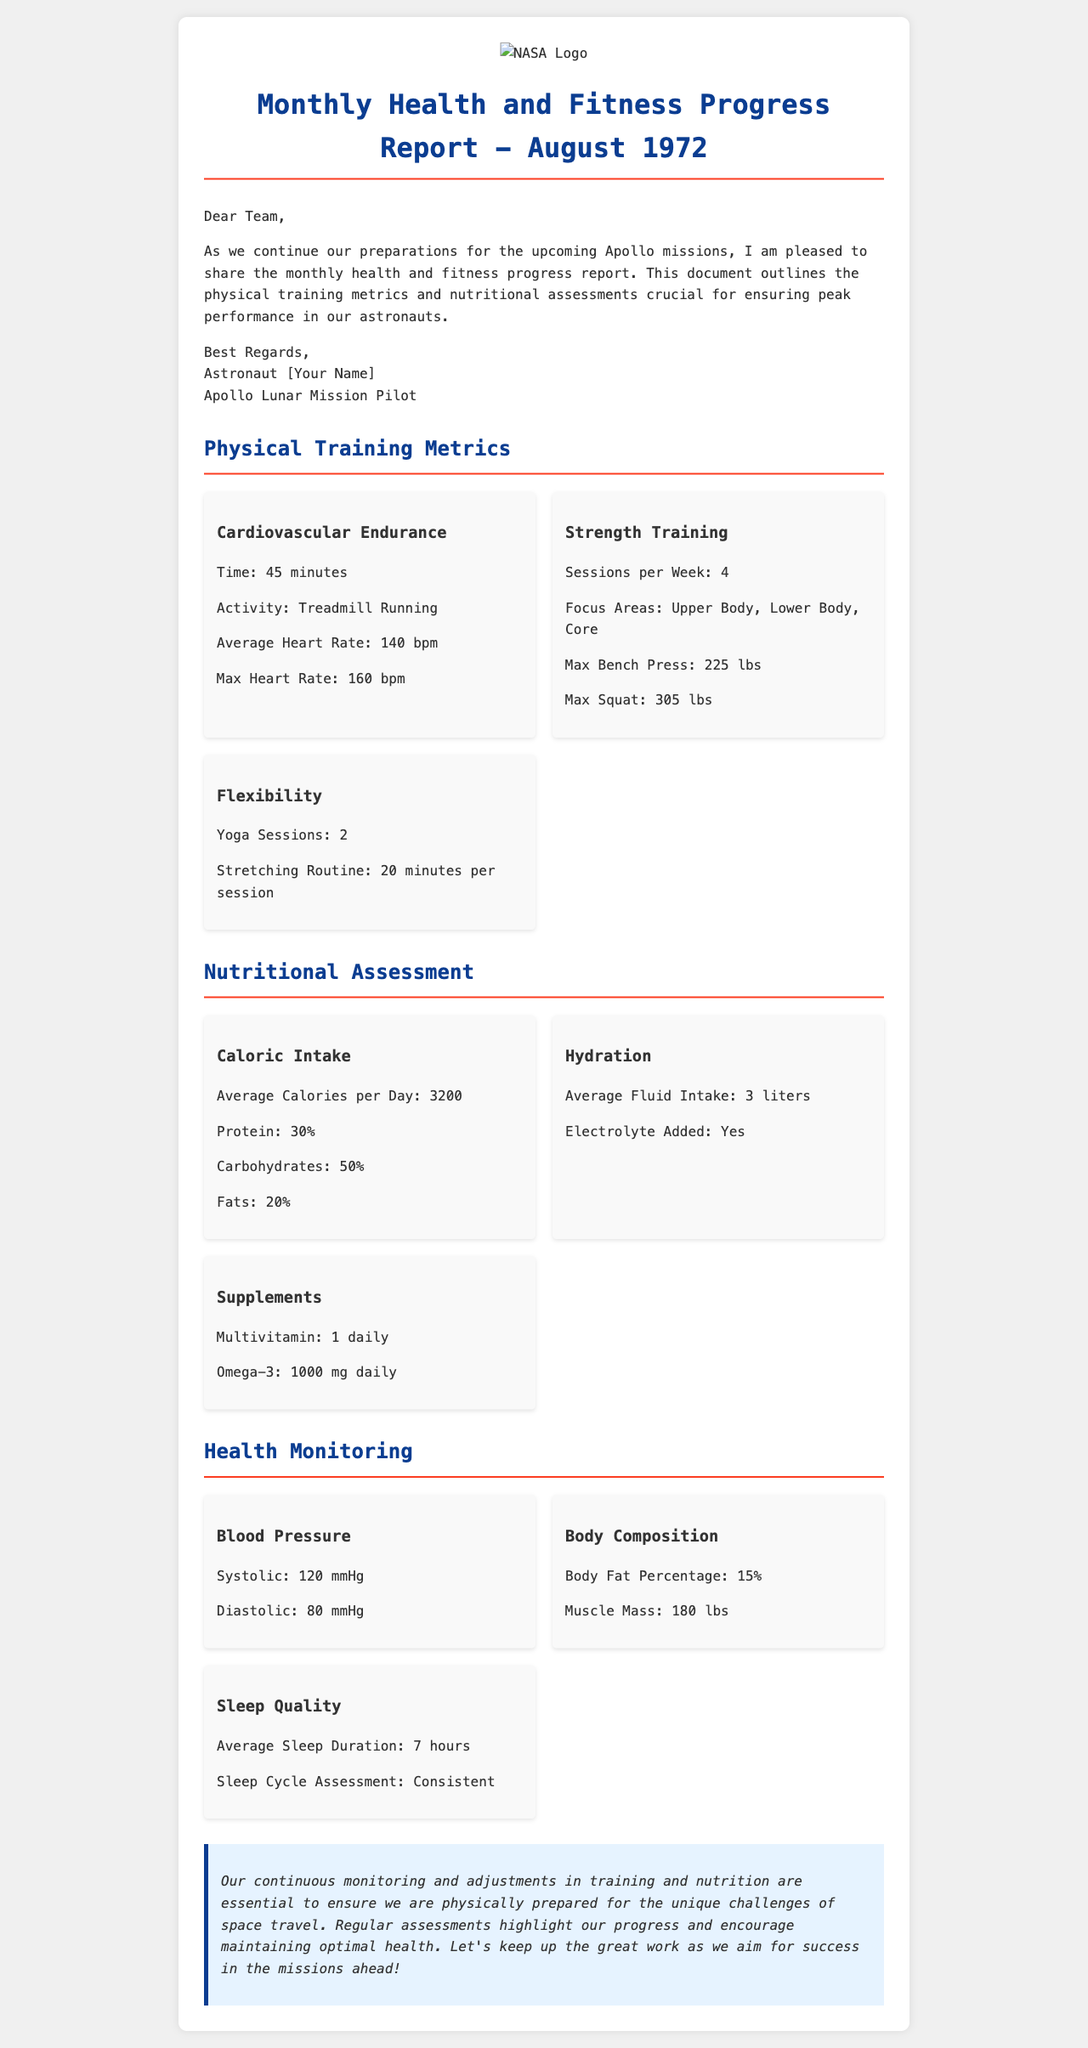what is the average heart rate during cardiovascular training? The average heart rate is mentioned in the cardiovascular endurance section of the report as 140 bpm.
Answer: 140 bpm how many strength training sessions are conducted per week? The report states that there are 4 sessions of strength training per week in the strength training section.
Answer: 4 what is the average caloric intake per day? The nutritional assessment section reveals that the average caloric intake is 3200 calories per day.
Answer: 3200 what is the body fat percentage? Body composition information includes the body fat percentage, which is stated as 15%.
Answer: 15% how many liters of fluid are consumed on average? The hydration section indicates an average fluid intake of 3 liters.
Answer: 3 liters what is the maximum bench press recorded? According to the strength training metrics, the maximum bench press is noted as 225 lbs.
Answer: 225 lbs how many hours of sleep is averaged? Sleep quality assessment mentions an average sleep duration of 7 hours.
Answer: 7 hours what type of training is included for flexibility? The flexibility section specifies yoga sessions and a stretching routine as part of the flexibility training.
Answer: Yoga sessions and stretching routine what is the conclusion emphasizing about astronaut health? The conclusion highlights the importance of continuous monitoring and adjustments to maintain optimal health for space travel.
Answer: Continuous monitoring and adjustments to maintain optimal health 